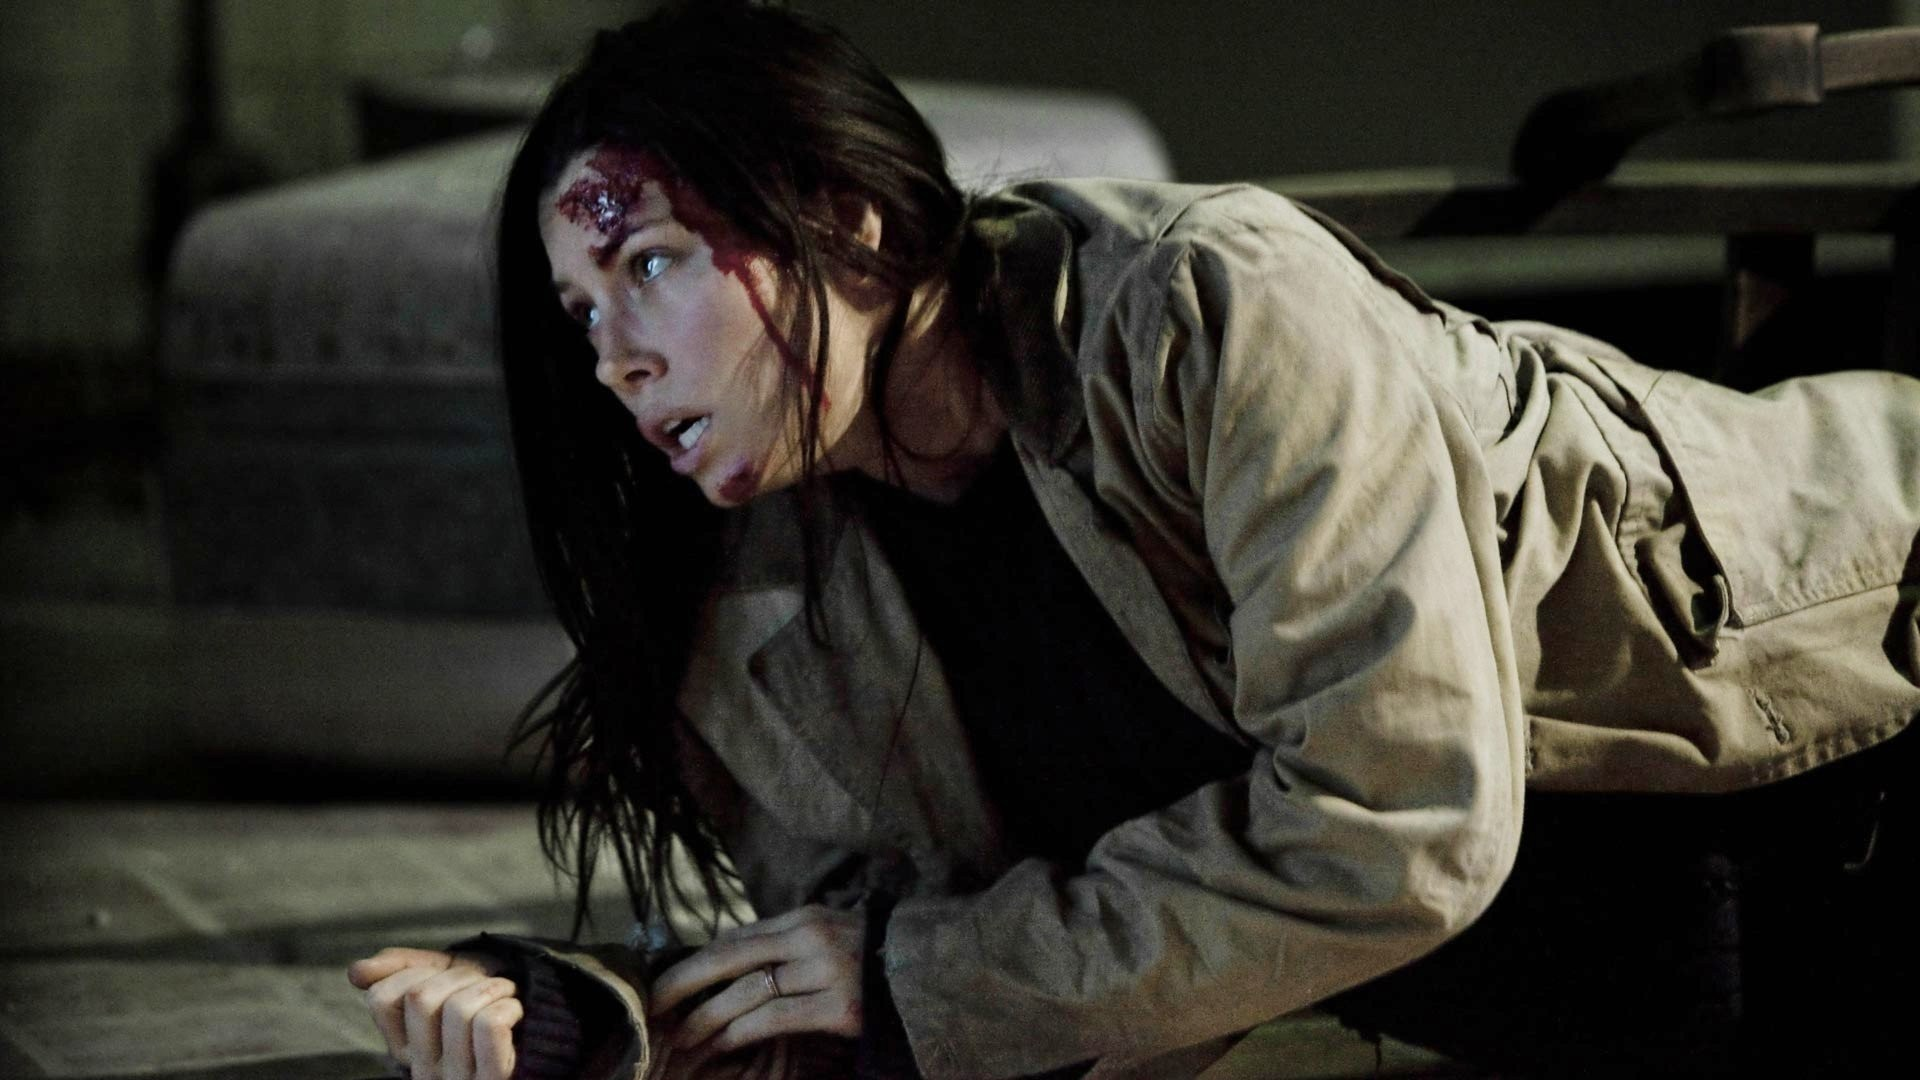Can you describe the main features of this image for me? In the image, a woman appears to be in a dramatic scene, possibly from a film or TV show. She is on the ground, crawling in what looks like an industrial or warehouse setting. The environment is dimly lit and adds a tense atmosphere to the scene. She has a bloody wound on her forehead, suggesting she has been involved in an altercation or an accident. Her expression shows shock or fear, implying she might be in a dangerous or threatening situation. Overall, the image conveys a sense of suspense and urgency. 